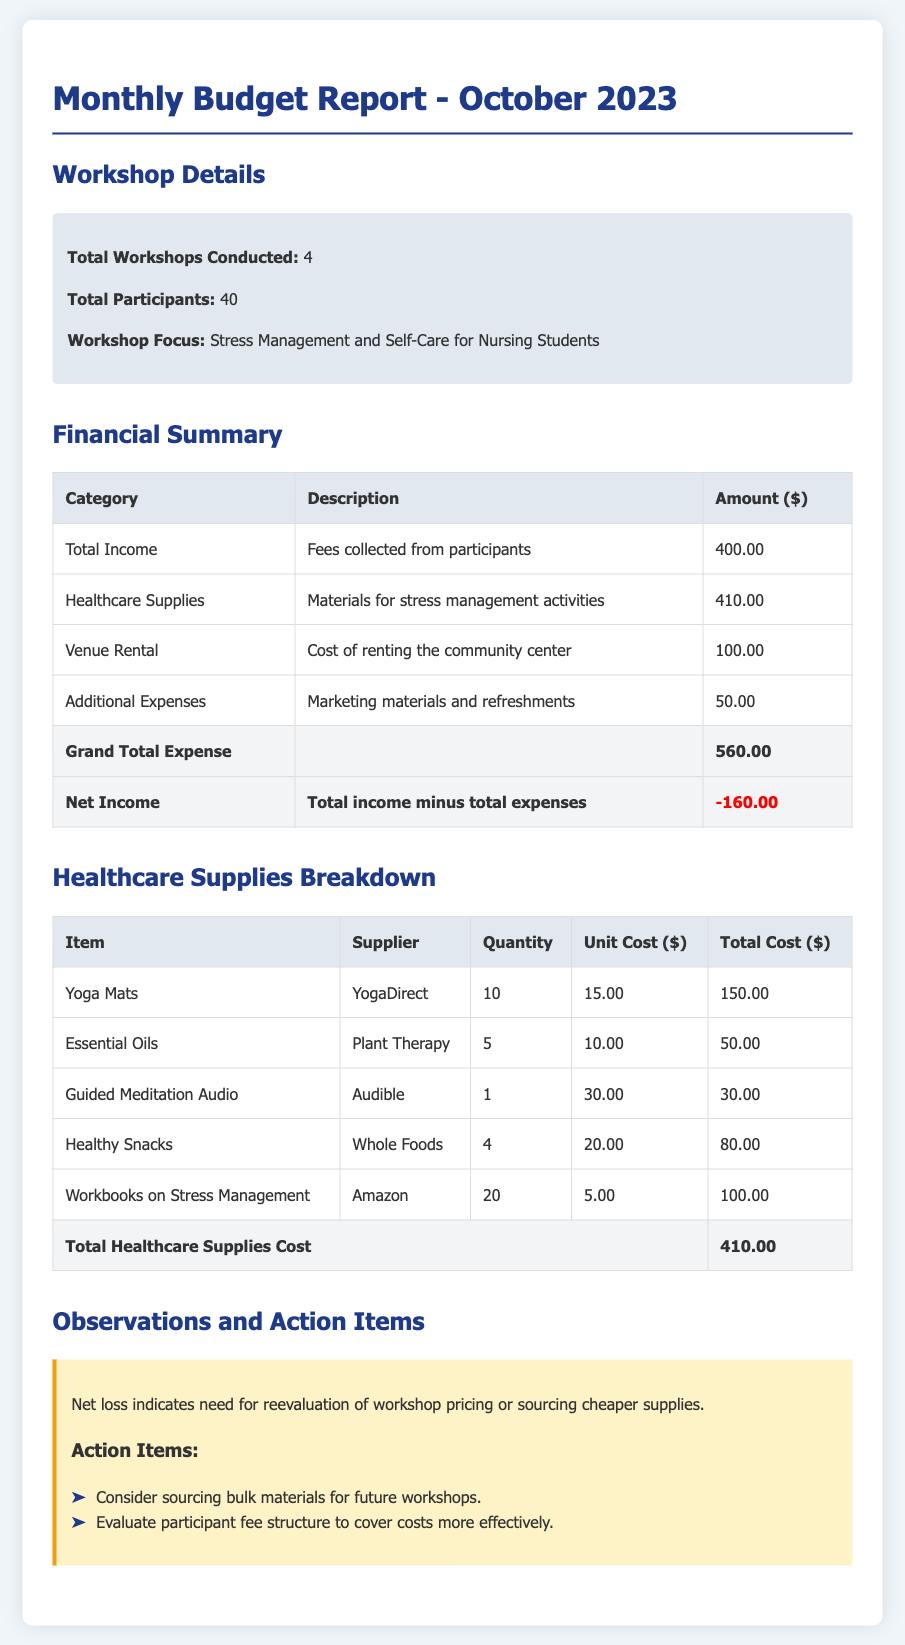What is the total number of workshops conducted? The total number of workshops conducted is stated in the workshop details section of the document.
Answer: 4 What is the total cost of healthcare supplies? The total cost of healthcare supplies can be found in the financial summary where the total healthcare supplies cost is listed.
Answer: 410.00 What was the total income from participant fees? The total income is described in the financial summary under the total income category, indicating the fees collected.
Answer: 400.00 What is the net income for the month? The net income is calculated as total income minus total expenses, which is provided in the financial summary.
Answer: -160.00 How many yoga mats were purchased? The quantity of yoga mats purchased is listed in the healthcare supplies breakdown table.
Answer: 10 What is the unit cost of essential oils? The unit cost of essential oils is listed in the healthcare supplies breakdown table under unit cost.
Answer: 10.00 What is the primary focus of the workshops? The primary focus of the workshops is stated in the workshop details section of the report.
Answer: Stress Management and Self-Care for Nursing Students What is one action item from the observations section? An action item is stated in the observations and action items section, providing a recommendation for future activities.
Answer: Consider sourcing bulk materials for future workshops What is the total amount spent on venue rental? The total amount spent on venue rental is detailed in the financial summary under the venue rental category.
Answer: 100.00 